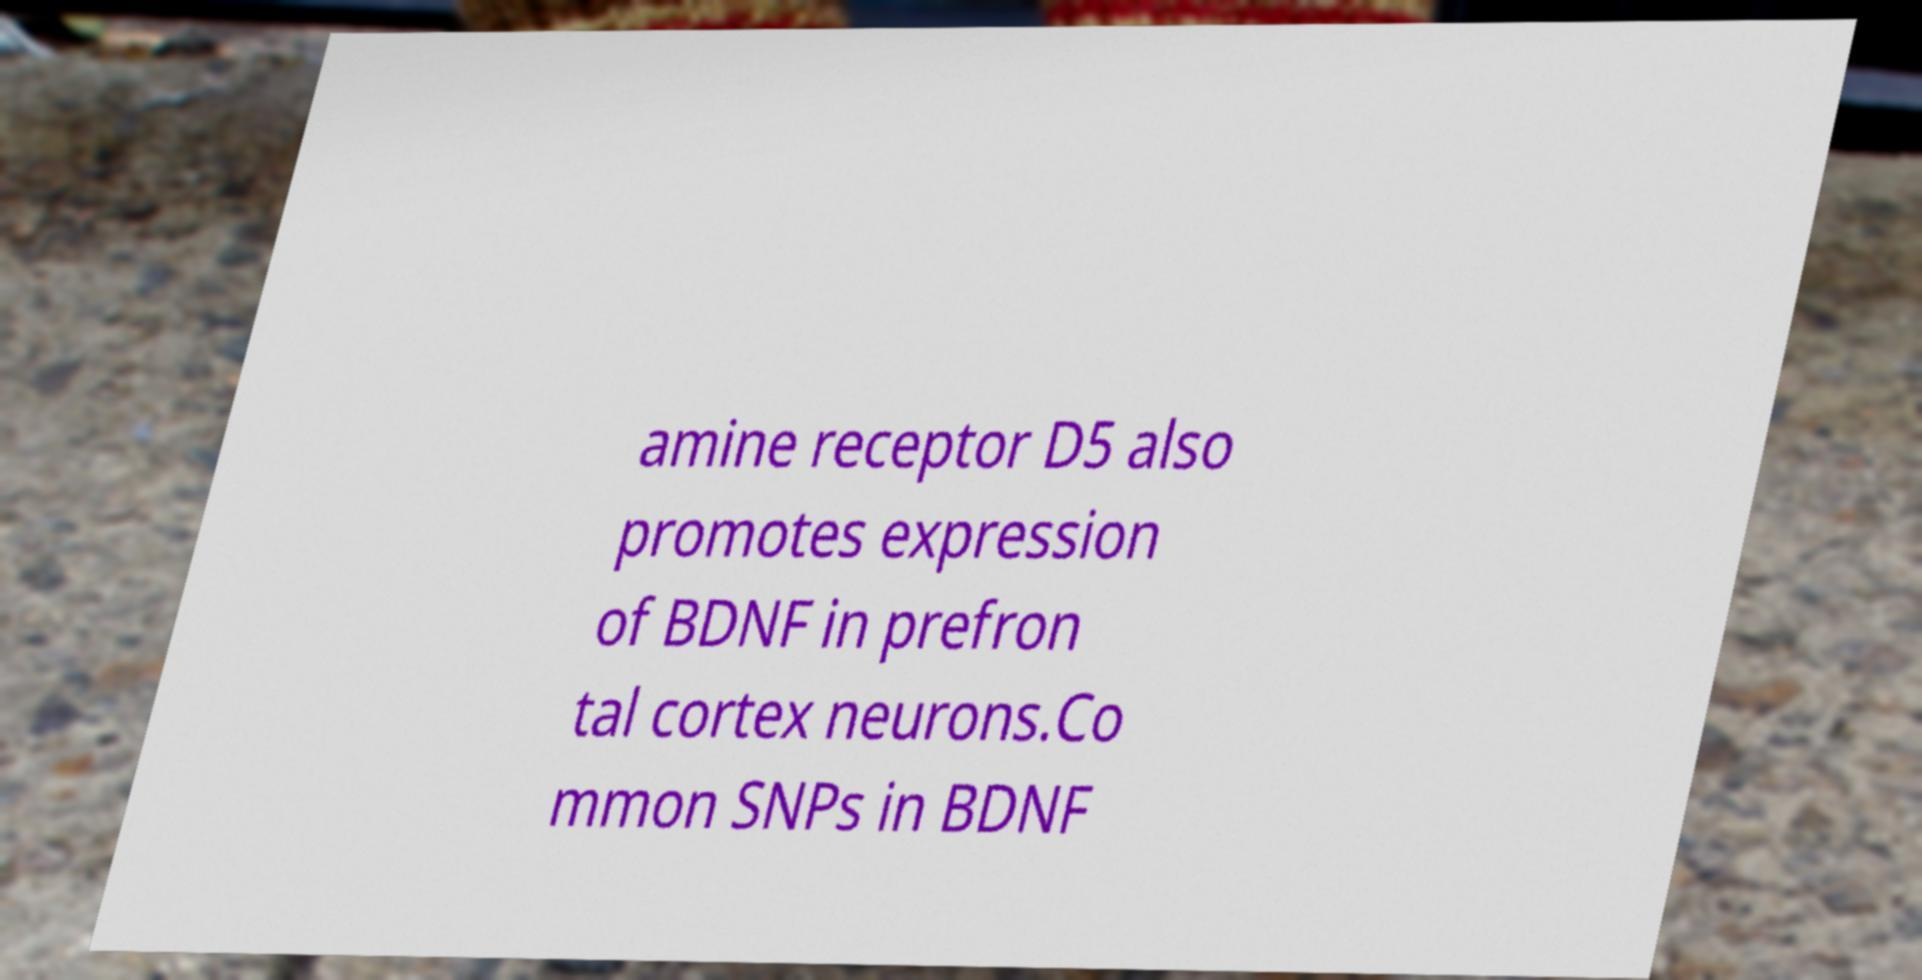Could you extract and type out the text from this image? amine receptor D5 also promotes expression of BDNF in prefron tal cortex neurons.Co mmon SNPs in BDNF 